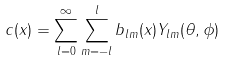<formula> <loc_0><loc_0><loc_500><loc_500>c ( x ) = \sum _ { l = 0 } ^ { \infty } \sum _ { m = - l } ^ { l } b _ { l m } ( x ) Y _ { l m } ( \theta , \phi )</formula> 